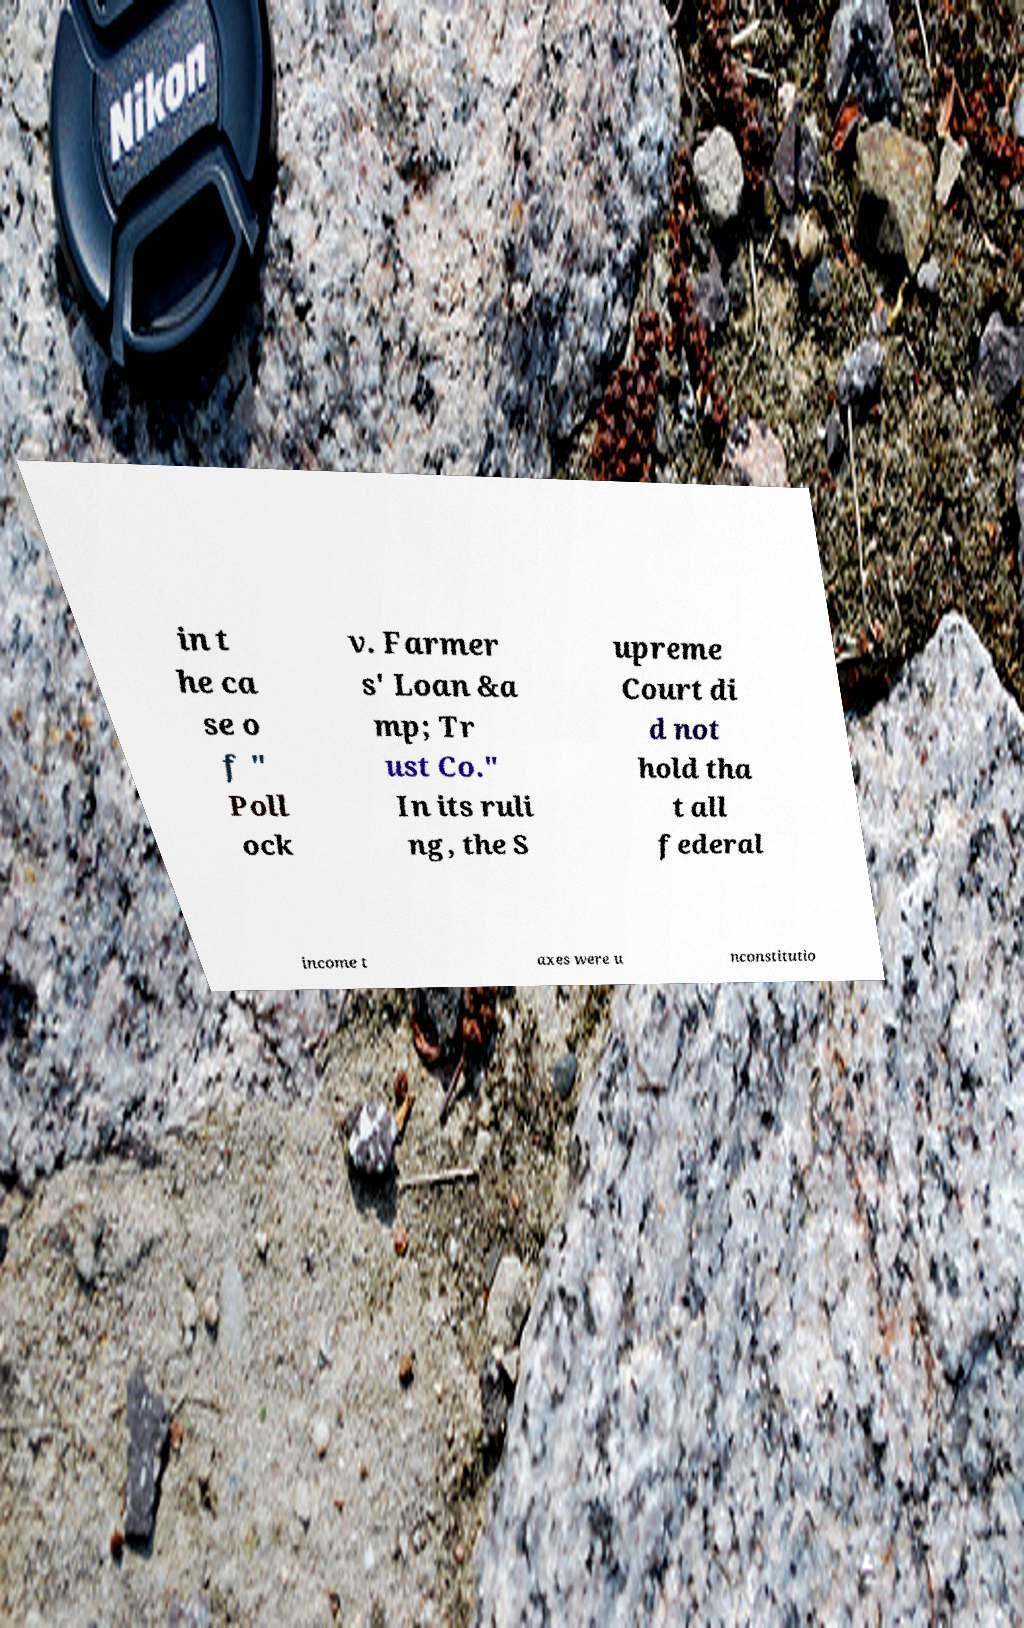What messages or text are displayed in this image? I need them in a readable, typed format. in t he ca se o f " Poll ock v. Farmer s' Loan &a mp; Tr ust Co." In its ruli ng, the S upreme Court di d not hold tha t all federal income t axes were u nconstitutio 